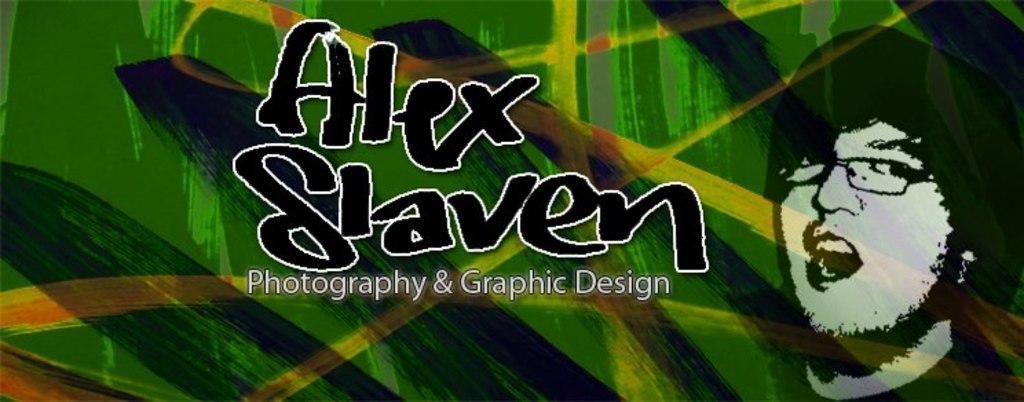Can you describe this image briefly? In this image we can see text and depiction of a person. 